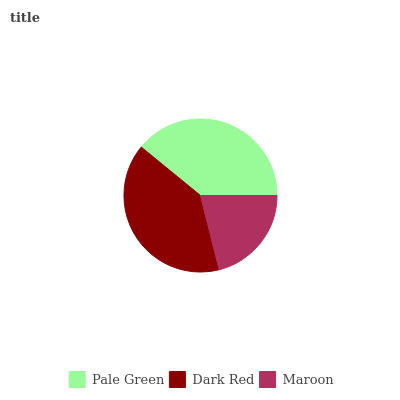Is Maroon the minimum?
Answer yes or no. Yes. Is Dark Red the maximum?
Answer yes or no. Yes. Is Dark Red the minimum?
Answer yes or no. No. Is Maroon the maximum?
Answer yes or no. No. Is Dark Red greater than Maroon?
Answer yes or no. Yes. Is Maroon less than Dark Red?
Answer yes or no. Yes. Is Maroon greater than Dark Red?
Answer yes or no. No. Is Dark Red less than Maroon?
Answer yes or no. No. Is Pale Green the high median?
Answer yes or no. Yes. Is Pale Green the low median?
Answer yes or no. Yes. Is Maroon the high median?
Answer yes or no. No. Is Maroon the low median?
Answer yes or no. No. 